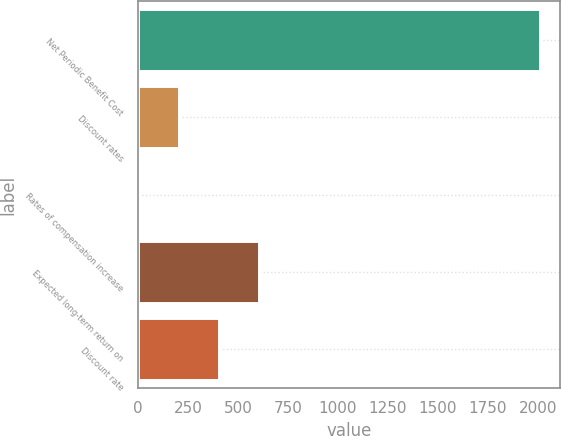Convert chart. <chart><loc_0><loc_0><loc_500><loc_500><bar_chart><fcel>Net Periodic Benefit Cost<fcel>Discount rates<fcel>Rates of compensation increase<fcel>Expected long-term return on<fcel>Discount rate<nl><fcel>2012<fcel>203.43<fcel>2.48<fcel>605.33<fcel>404.38<nl></chart> 